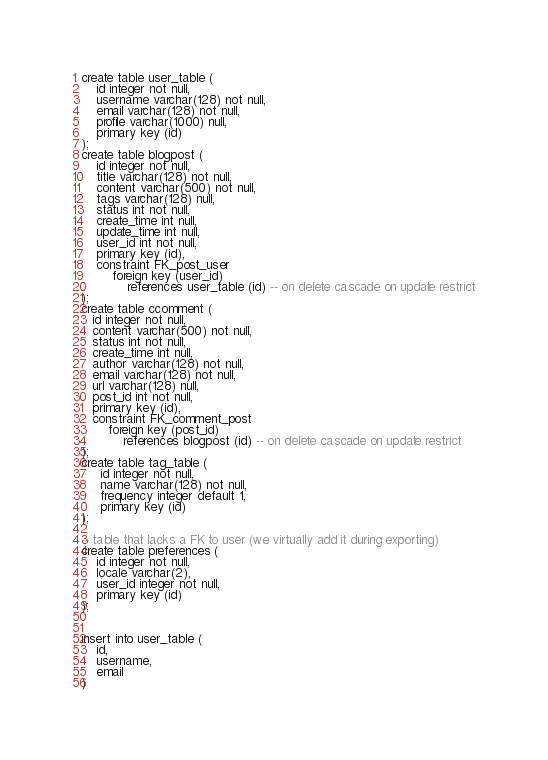Convert code to text. <code><loc_0><loc_0><loc_500><loc_500><_SQL_>create table user_table (
    id integer not null,
    username varchar(128) not null,
    email varchar(128) not null,
    profile varchar(1000) null,
    primary key (id)
);
create table blogpost (
    id integer not null,
    title varchar(128) not null,
    content varchar(500) not null,
    tags varchar(128) null,
    status int not null,
    create_time int null,
    update_time int null,
    user_id int not null,
    primary key (id),
    constraint FK_post_user
        foreign key (user_id)
            references user_table (id) -- on delete cascade on update restrict
);
create table ccomment (
   id integer not null,
   content varchar(500) not null,
   status int not null,
   create_time int null,
   author varchar(128) not null,
   email varchar(128) not null,
   url varchar(128) null,
   post_id int not null,
   primary key (id),
   constraint FK_comment_post
       foreign key (post_id)
           references blogpost (id) -- on delete cascade on update restrict
);
create table tag_table (
     id integer not null,
     name varchar(128) not null,
     frequency integer default 1,
     primary key (id)
);

-- table that lacks a FK to user (we virtually add it during exporting)
create table preferences (
    id integer not null,
    locale varchar(2),
    user_id integer not null,
    primary key (id)
);


insert into user_table (
    id,
    username,
    email
)</code> 